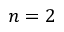Convert formula to latex. <formula><loc_0><loc_0><loc_500><loc_500>n = 2</formula> 